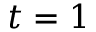<formula> <loc_0><loc_0><loc_500><loc_500>t = 1</formula> 